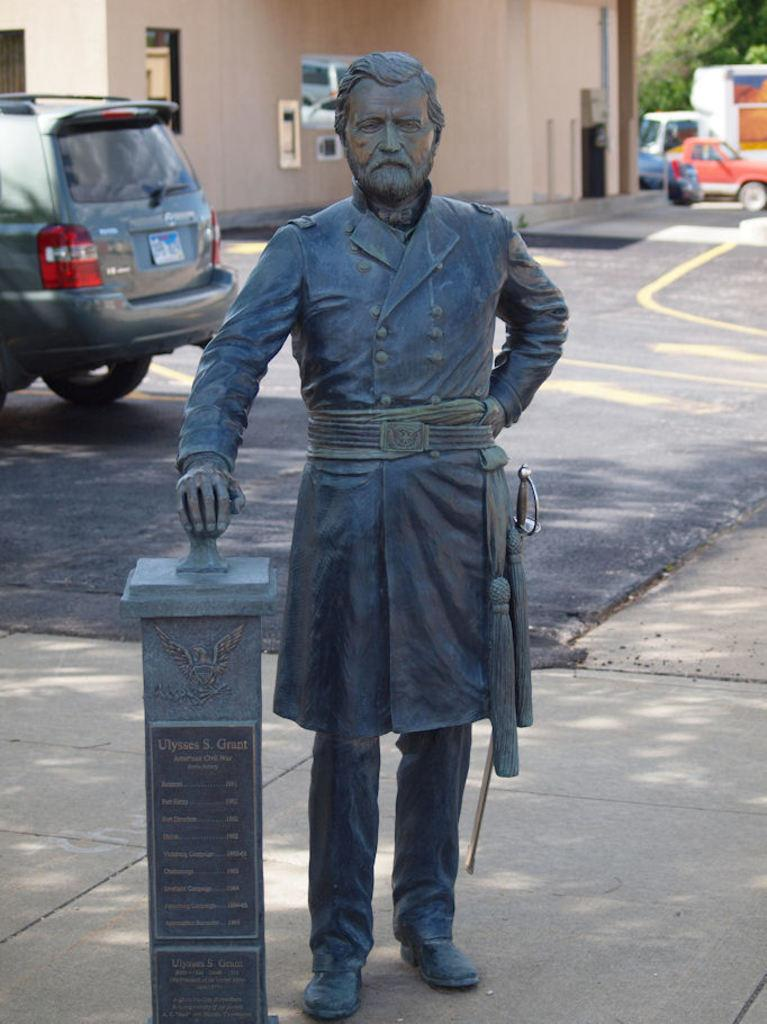What is the main subject in the image? There is a statue in the image. What else can be seen in the image besides the statue? There are vehicles on the road and trees and a building in the background of the image. What type of party is being held at the statue in the image? There is no party present in the image; it only features a statue, vehicles, trees, and a building. What is the servant's role in relation to the statue in the image? There is no servant present in the image; it only features a statue, vehicles, trees, and a building. 